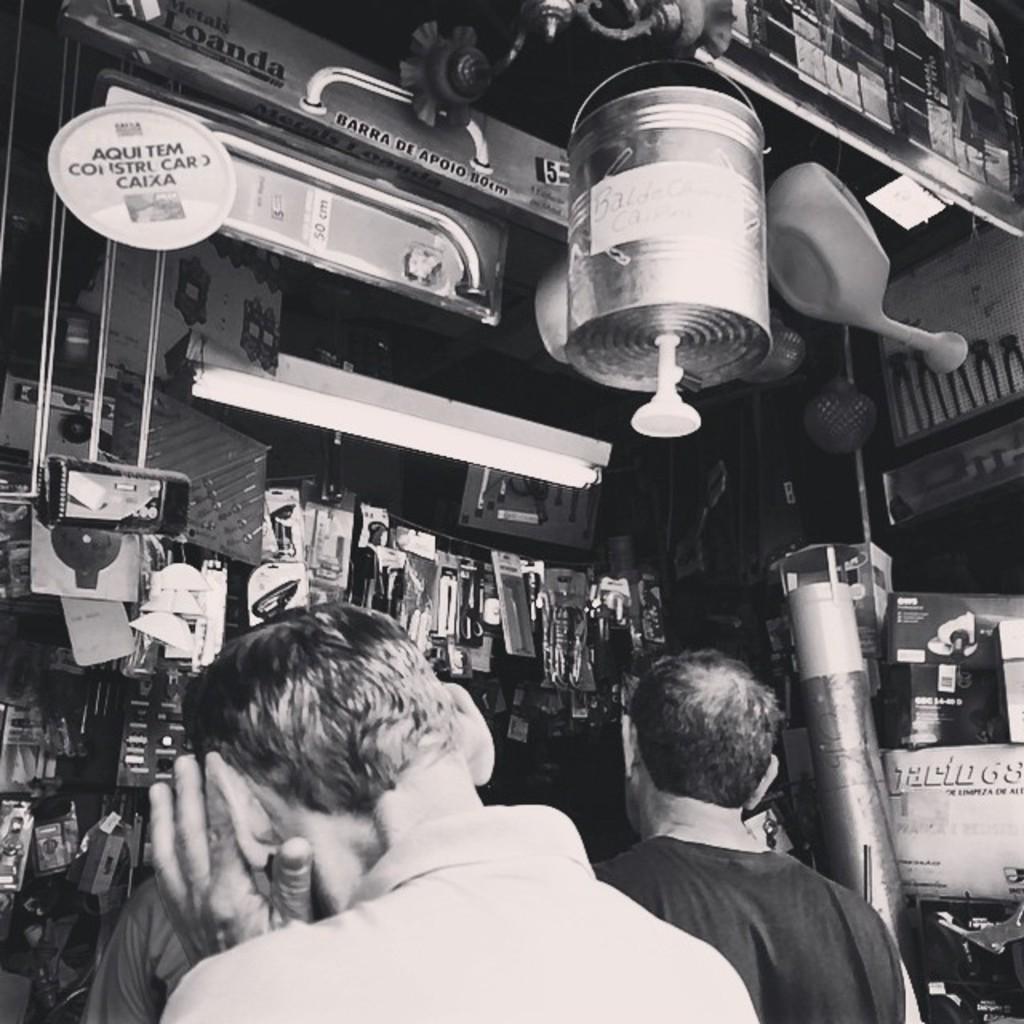Please provide a concise description of this image. In this picture we can see three people and in the background we can see a tube light, posters and some objects. 